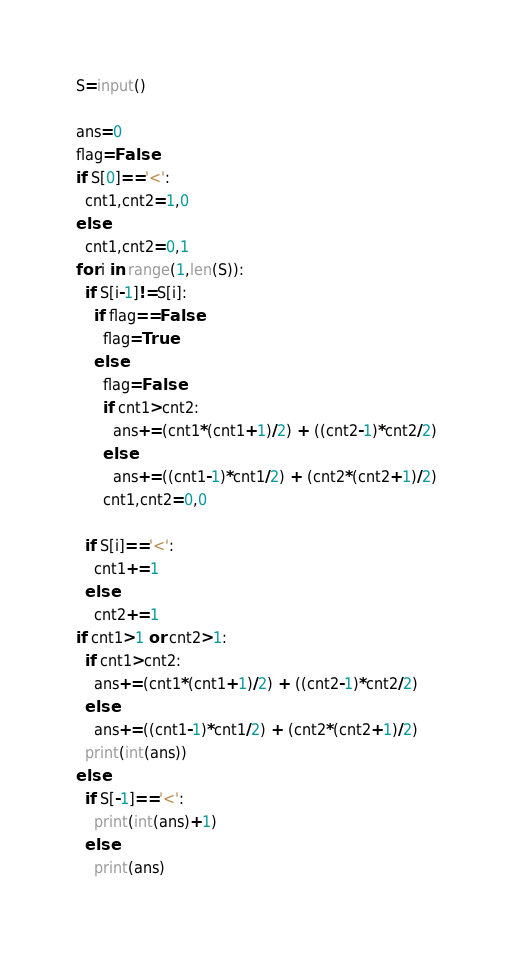Convert code to text. <code><loc_0><loc_0><loc_500><loc_500><_Python_>S=input()

ans=0
flag=False
if S[0]=='<':
  cnt1,cnt2=1,0
else:
  cnt1,cnt2=0,1  
for i in range(1,len(S)):
  if S[i-1]!=S[i]:
    if flag==False:
      flag=True
    else:
      flag=False
      if cnt1>cnt2:
        ans+=(cnt1*(cnt1+1)/2) + ((cnt2-1)*cnt2/2)
      else:
        ans+=((cnt1-1)*cnt1/2) + (cnt2*(cnt2+1)/2)
      cnt1,cnt2=0,0
    
  if S[i]=='<':
    cnt1+=1
  else:
    cnt2+=1
if cnt1>1 or cnt2>1:
  if cnt1>cnt2:
    ans+=(cnt1*(cnt1+1)/2) + ((cnt2-1)*cnt2/2)
  else:
    ans+=((cnt1-1)*cnt1/2) + (cnt2*(cnt2+1)/2)
  print(int(ans))
else:
  if S[-1]=='<':
    print(int(ans)+1)
  else:
    print(ans)</code> 